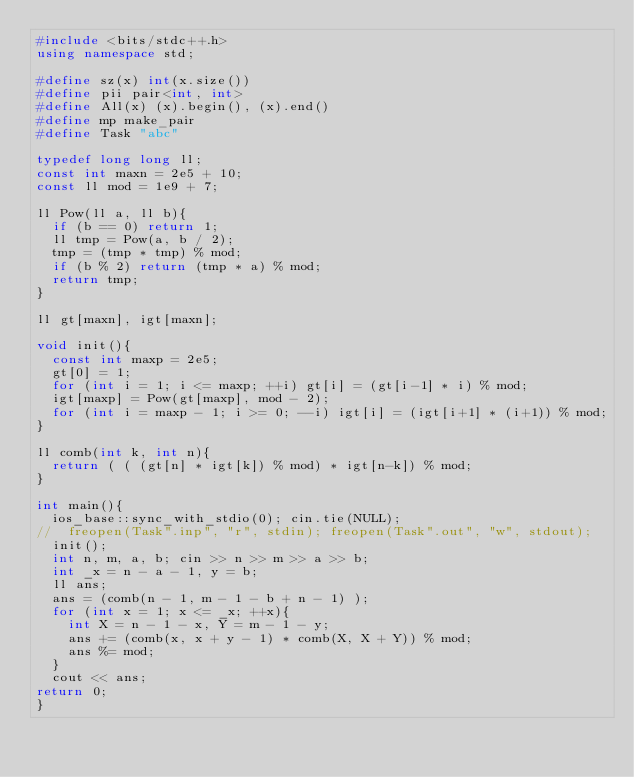<code> <loc_0><loc_0><loc_500><loc_500><_C++_>#include <bits/stdc++.h>
using namespace std;

#define sz(x) int(x.size())
#define pii pair<int, int>
#define All(x) (x).begin(), (x).end()
#define mp make_pair
#define Task "abc"

typedef long long ll;
const int maxn = 2e5 + 10;
const ll mod = 1e9 + 7;

ll Pow(ll a, ll b){
  if (b == 0) return 1;
  ll tmp = Pow(a, b / 2);
  tmp = (tmp * tmp) % mod;
  if (b % 2) return (tmp * a) % mod;
  return tmp;
}

ll gt[maxn], igt[maxn];

void init(){
  const int maxp = 2e5;
  gt[0] = 1;
  for (int i = 1; i <= maxp; ++i) gt[i] = (gt[i-1] * i) % mod;
  igt[maxp] = Pow(gt[maxp], mod - 2);
  for (int i = maxp - 1; i >= 0; --i) igt[i] = (igt[i+1] * (i+1)) % mod;
}

ll comb(int k, int n){
  return ( ( (gt[n] * igt[k]) % mod) * igt[n-k]) % mod;
}

int main(){
  ios_base::sync_with_stdio(0); cin.tie(NULL);
//  freopen(Task".inp", "r", stdin); freopen(Task".out", "w", stdout);
  init();
  int n, m, a, b; cin >> n >> m >> a >> b;
  int _x = n - a - 1, y = b;
  ll ans;
  ans = (comb(n - 1, m - 1 - b + n - 1) );
  for (int x = 1; x <= _x; ++x){
    int X = n - 1 - x, Y = m - 1 - y;
    ans += (comb(x, x + y - 1) * comb(X, X + Y)) % mod;
    ans %= mod;
  }
  cout << ans;
return 0;
}


</code> 